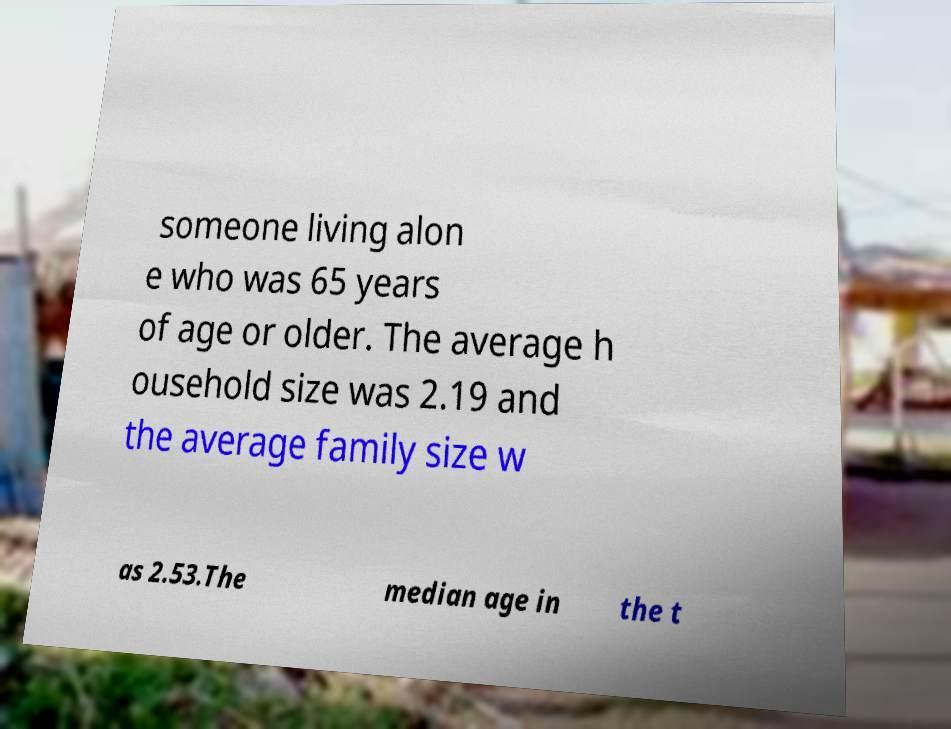For documentation purposes, I need the text within this image transcribed. Could you provide that? someone living alon e who was 65 years of age or older. The average h ousehold size was 2.19 and the average family size w as 2.53.The median age in the t 